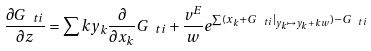Convert formula to latex. <formula><loc_0><loc_0><loc_500><loc_500>\frac { \partial G _ { \ t i } } { \partial z } = \sum k y _ { k } \frac { \partial } { \partial x _ { k } } G _ { \ t i } + \frac { v ^ { E } } w e ^ { \sum ( x _ { k } + { G } _ { \ t i } | _ { y _ { k } \mapsto y _ { k } + k w } ) - G _ { \ t i } }</formula> 